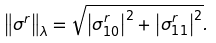Convert formula to latex. <formula><loc_0><loc_0><loc_500><loc_500>\left \| \sigma ^ { r } \right \| _ { \lambda } = \sqrt { \left | \sigma _ { 1 0 } ^ { r } \right | ^ { 2 } + \left | \sigma _ { 1 1 } ^ { r } \right | ^ { 2 } } .</formula> 